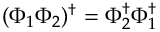Convert formula to latex. <formula><loc_0><loc_0><loc_500><loc_500>( \Phi _ { 1 } \Phi _ { 2 } ) ^ { \dagger } = \Phi _ { 2 } ^ { \dagger } \Phi _ { 1 } ^ { \dagger }</formula> 